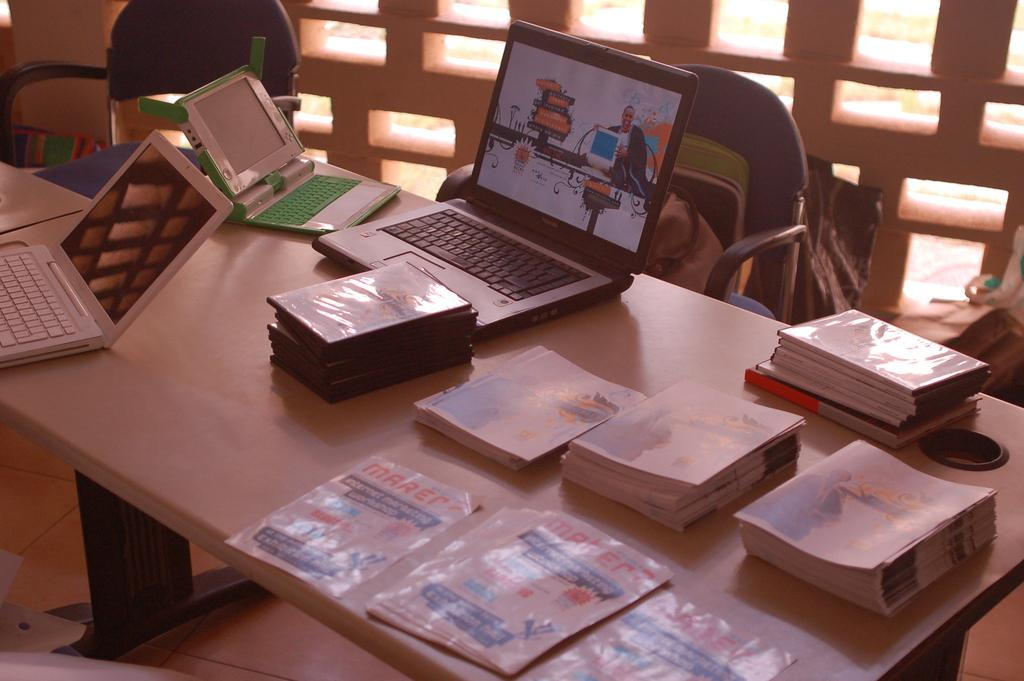What objects are on the table in the image? There are books and laptops on the table in the image. What type of furniture is present in the image? There are chairs in the image. Can you see an owl sitting on the books in the image? No, there is no owl present in the image. What type of bun is being served on the table in the image? There is no bun present in the image; the main objects on the table are books and laptops. 